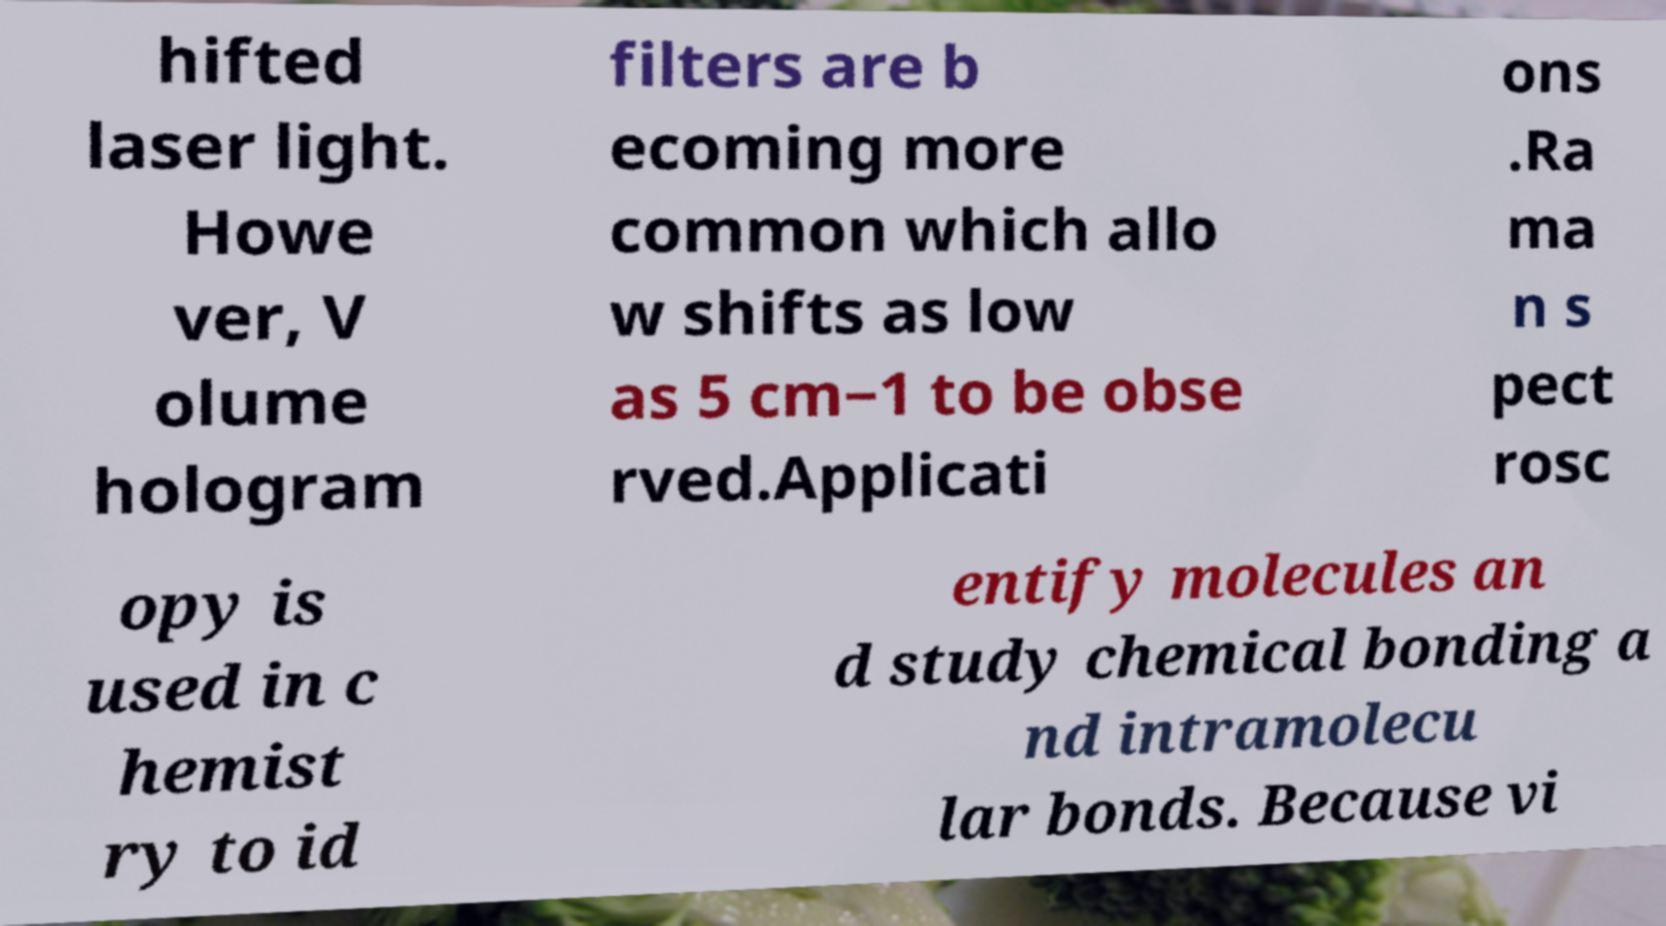Please read and relay the text visible in this image. What does it say? hifted laser light. Howe ver, V olume hologram filters are b ecoming more common which allo w shifts as low as 5 cm−1 to be obse rved.Applicati ons .Ra ma n s pect rosc opy is used in c hemist ry to id entify molecules an d study chemical bonding a nd intramolecu lar bonds. Because vi 